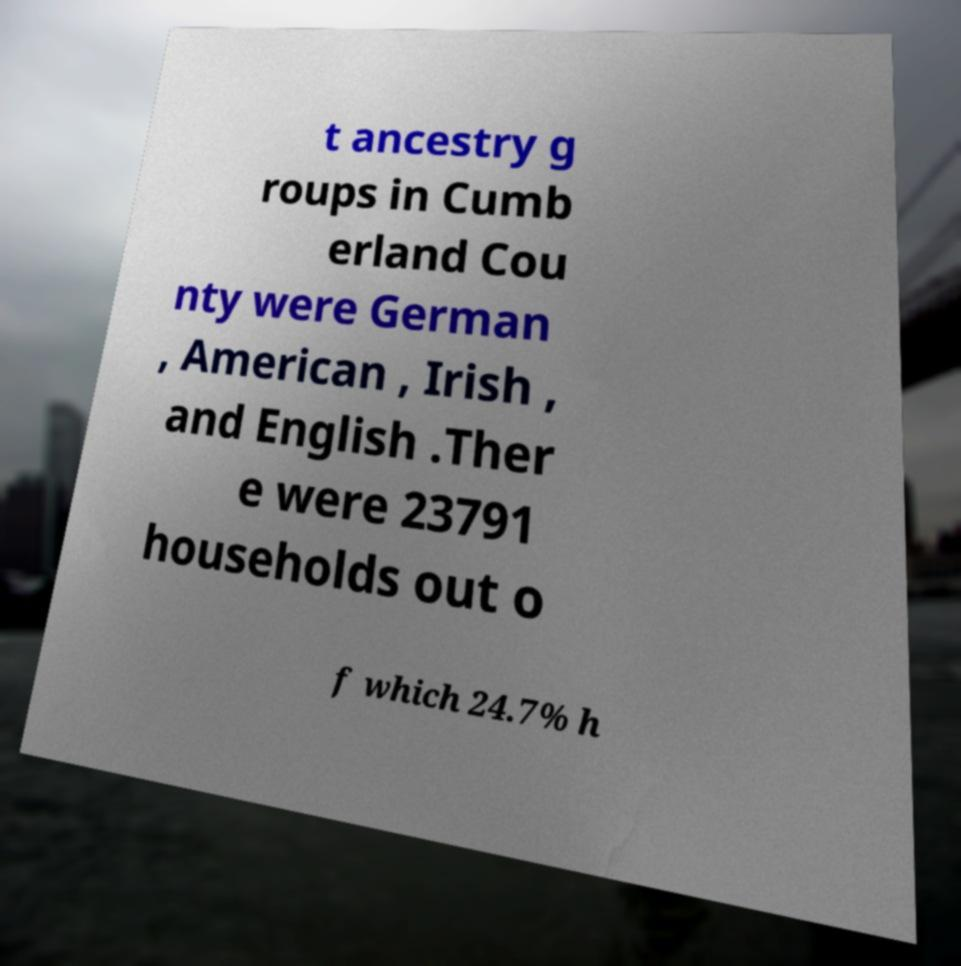There's text embedded in this image that I need extracted. Can you transcribe it verbatim? t ancestry g roups in Cumb erland Cou nty were German , American , Irish , and English .Ther e were 23791 households out o f which 24.7% h 